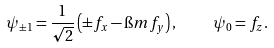Convert formula to latex. <formula><loc_0><loc_0><loc_500><loc_500>\psi _ { \pm 1 } = \frac { 1 } { \sqrt { 2 } } \left ( \pm f _ { x } - \i m f _ { y } \right ) , \quad \psi _ { 0 } = f _ { z } .</formula> 